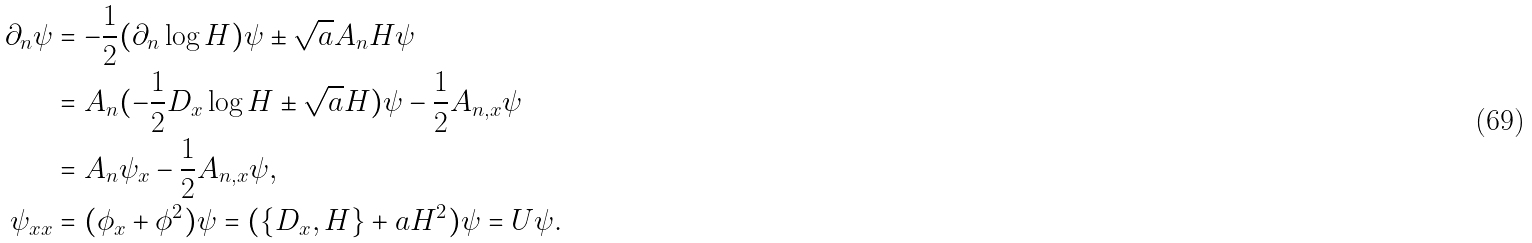<formula> <loc_0><loc_0><loc_500><loc_500>\partial _ { n } \psi & = - \frac { 1 } { 2 } ( \partial _ { n } \log H ) \psi \pm \sqrt { a } A _ { n } H \psi \\ & = A _ { n } ( - \frac { 1 } { 2 } D _ { x } \log H \pm \sqrt { a } H ) \psi - \frac { 1 } { 2 } A _ { n , x } \psi \\ & = A _ { n } \psi _ { x } - \frac { 1 } { 2 } A _ { n , x } \psi , \\ \psi _ { x x } & = ( \phi _ { x } + \phi ^ { 2 } ) \psi = ( \{ D _ { x } , H \} + a H ^ { 2 } ) \psi = U \psi .</formula> 